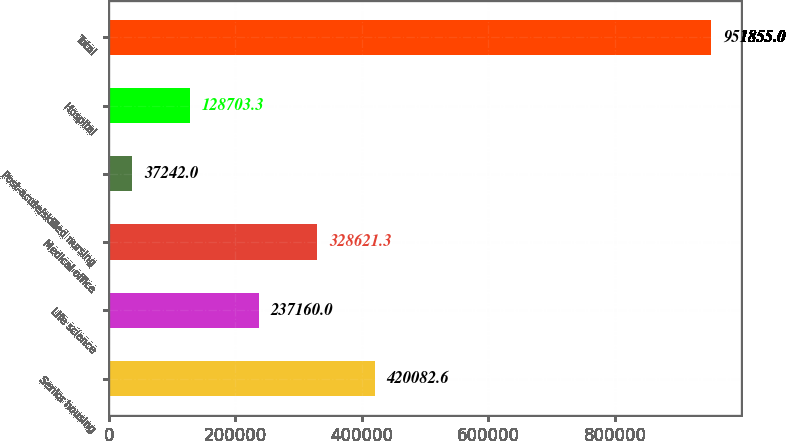<chart> <loc_0><loc_0><loc_500><loc_500><bar_chart><fcel>Senior housing<fcel>Life science<fcel>Medical office<fcel>Post-acute/skilled nursing<fcel>Hospital<fcel>Total<nl><fcel>420083<fcel>237160<fcel>328621<fcel>37242<fcel>128703<fcel>951855<nl></chart> 